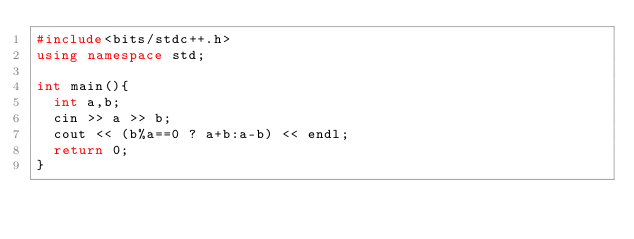Convert code to text. <code><loc_0><loc_0><loc_500><loc_500><_C++_>#include<bits/stdc++.h>
using namespace std;

int main(){
  int a,b;
  cin >> a >> b;
  cout << (b%a==0 ? a+b:a-b) << endl;
  return 0;
}</code> 